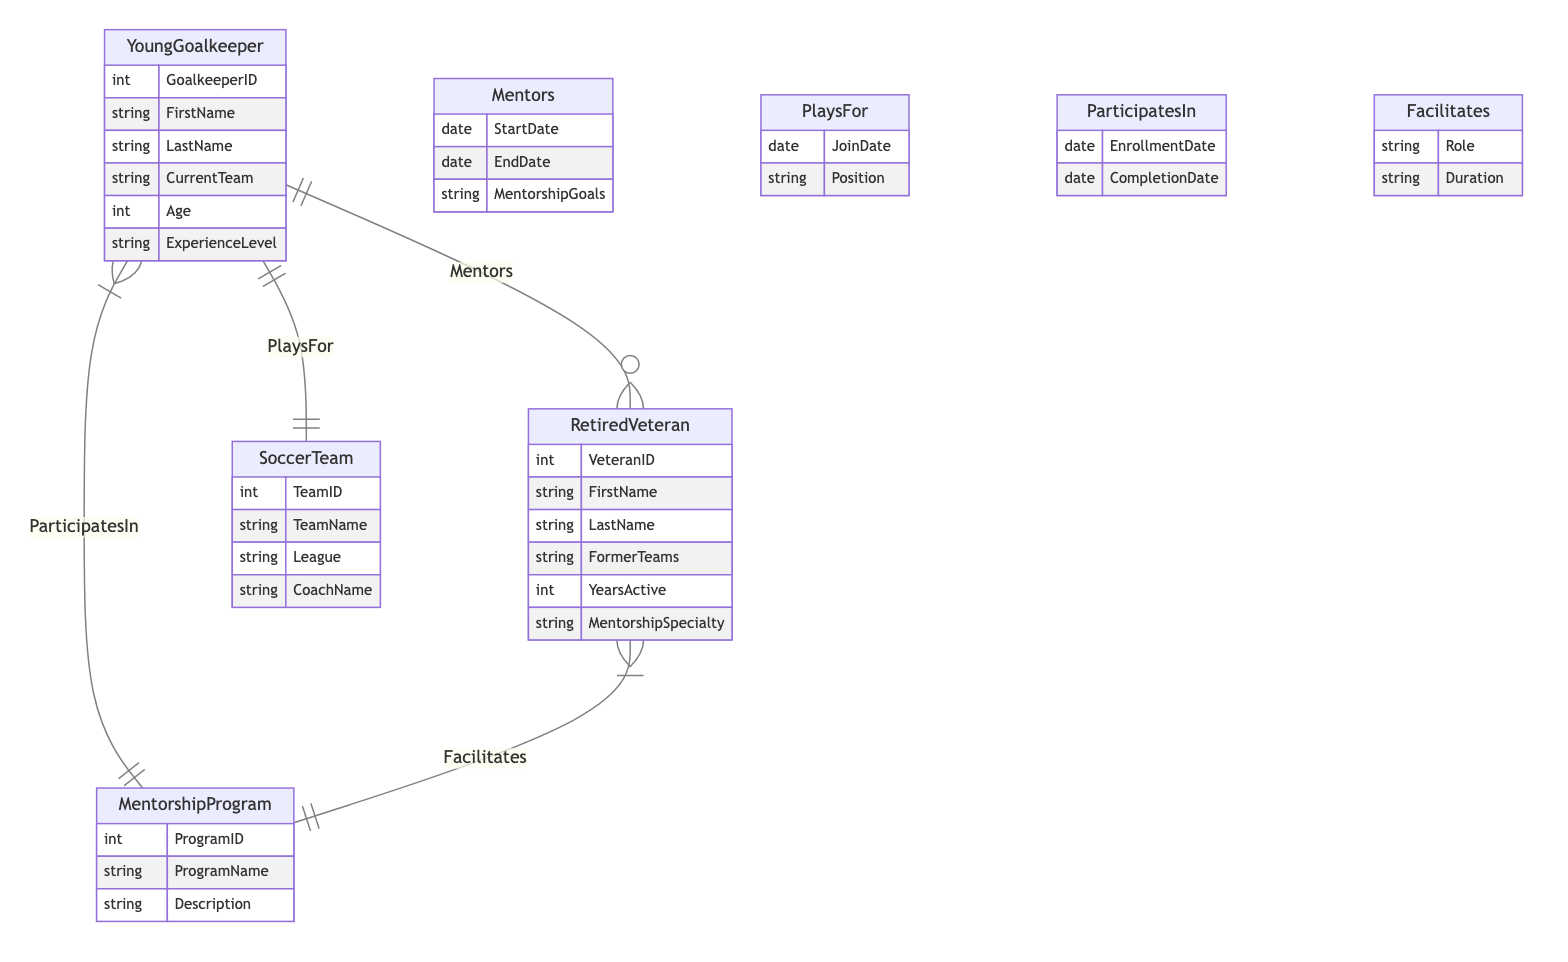What is the primary relationship between Young Goalkeeper and Retired Veteran? The primary relationship shown is "Mentors," which connects Young Goalkeeper to Retired Veteran. This indicates that young goalkeepers receive guidance from retired veterans.
Answer: Mentors How many attributes does the Young Goalkeeper entity have? The Young Goalkeeper entity has six attributes: GoalkeeperID, FirstName, LastName, CurrentTeam, Age, and ExperienceLevel.
Answer: Six What is the cardinality of the relationship between Retired Veteran and Mentorship Program? The diagram shows that Retired Veteran can facilitate multiple Mentorship Programs. This indicates a one-to-many relationship, as one veteran can be linked to multiple programs.
Answer: One-to-many What attribute indicates the age of a Young Goalkeeper? The attribute that indicates the age of a Young Goalkeeper is "Age," which is expressly listed in the entity's attributes.
Answer: Age What is the role of a Retired Veteran in a Mentorship Program? The role of a Retired Veteran in a Mentorship Program is indicated by the "Role" attribute within the "Facilitates" relationship. This signifies their involvement in guiding participants.
Answer: Role During which relationship does a Young Goalkeeper's Join Date get recorded? The Join Date for a Young Goalkeeper is recorded in the "Plays For" relationship, indicating the date they joined a specific soccer team.
Answer: Plays For What signifies that a Young Goalkeeper participates in a Mentorship Program? The attribute "EnrollmentDate" in the "Participates In" relationship signifies that a Young Goalkeeper has enrolled in a Mentorship Program and indicates the date they started.
Answer: EnrollmentDate How many entities are involved in the diagram? The diagram has four main entities: Young Goalkeeper, Retired Veteran, Soccer Team, and Mentorship Program.
Answer: Four What relationship connects Soccer Team to Young Goalkeeper? The relationship connecting Soccer Team to Young Goalkeeper is called "Plays For," which indicates which soccer team the goalkeeper is part of.
Answer: Plays For 